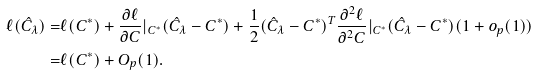Convert formula to latex. <formula><loc_0><loc_0><loc_500><loc_500>\ell ( \hat { C } _ { \lambda } ) = & \ell ( C ^ { * } ) + \frac { \partial { \ell } } { \partial C } | _ { C ^ { * } } ( \hat { C } _ { \lambda } - C ^ { * } ) + \frac { 1 } { 2 } ( \hat { C } _ { \lambda } - C ^ { * } ) ^ { T } \frac { \partial ^ { 2 } { \ell } } { \partial ^ { 2 } C } | _ { C ^ { * } } ( \hat { C } _ { \lambda } - C ^ { * } ) ( 1 + o _ { p } ( 1 ) ) \\ = & \ell ( C ^ { * } ) + O _ { p } ( 1 ) .</formula> 